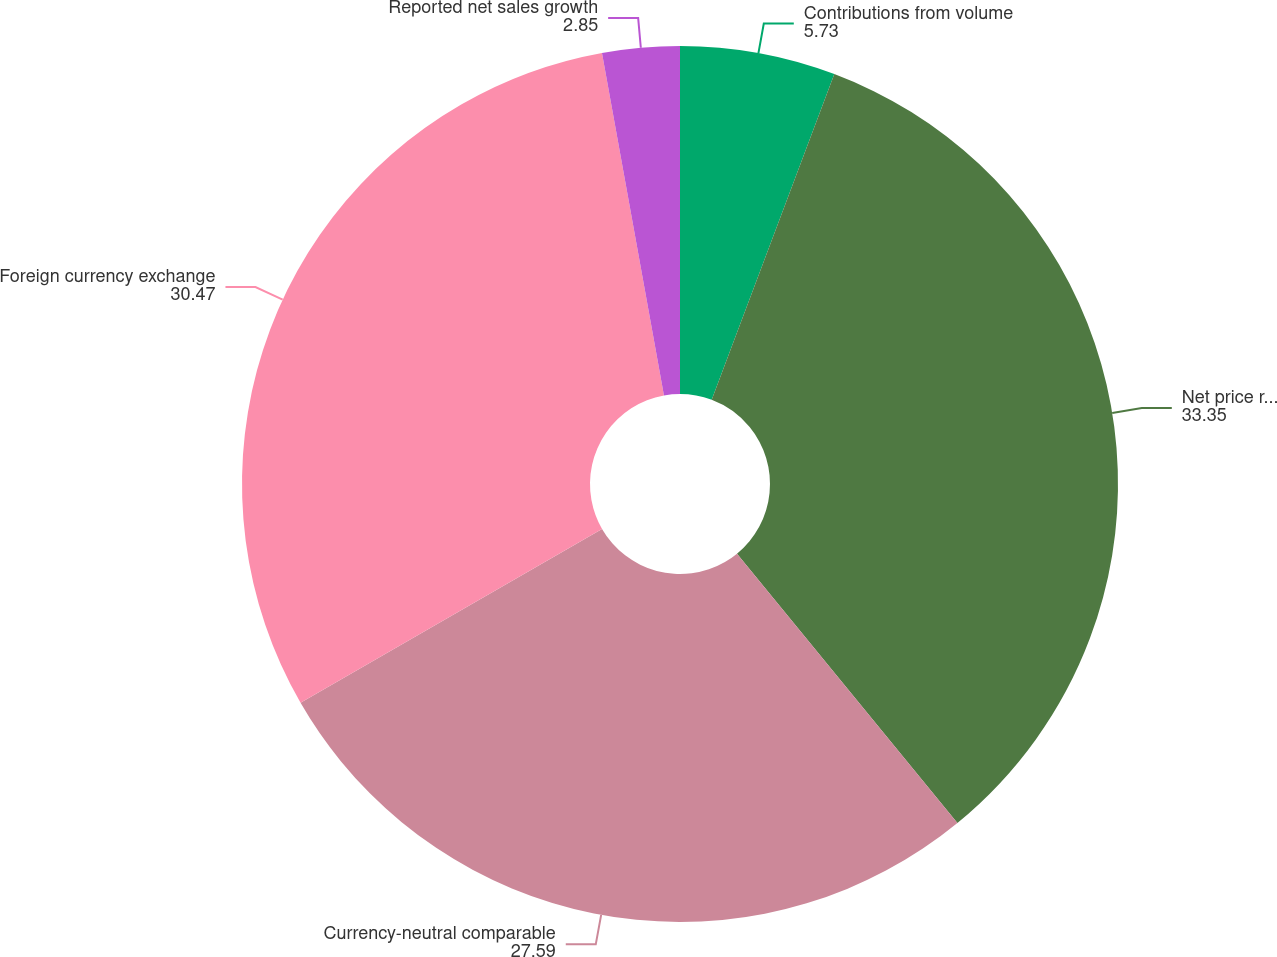<chart> <loc_0><loc_0><loc_500><loc_500><pie_chart><fcel>Contributions from volume<fcel>Net price realization and mix<fcel>Currency-neutral comparable<fcel>Foreign currency exchange<fcel>Reported net sales growth<nl><fcel>5.73%<fcel>33.35%<fcel>27.59%<fcel>30.47%<fcel>2.85%<nl></chart> 